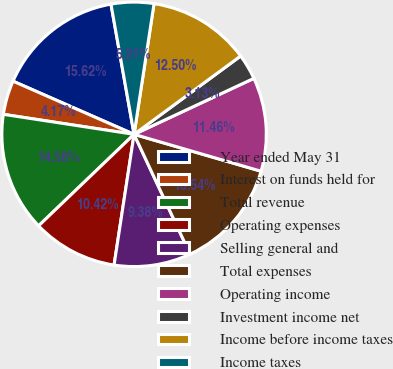<chart> <loc_0><loc_0><loc_500><loc_500><pie_chart><fcel>Year ended May 31<fcel>Interest on funds held for<fcel>Total revenue<fcel>Operating expenses<fcel>Selling general and<fcel>Total expenses<fcel>Operating income<fcel>Investment income net<fcel>Income before income taxes<fcel>Income taxes<nl><fcel>15.62%<fcel>4.17%<fcel>14.58%<fcel>10.42%<fcel>9.38%<fcel>13.54%<fcel>11.46%<fcel>3.13%<fcel>12.5%<fcel>5.21%<nl></chart> 